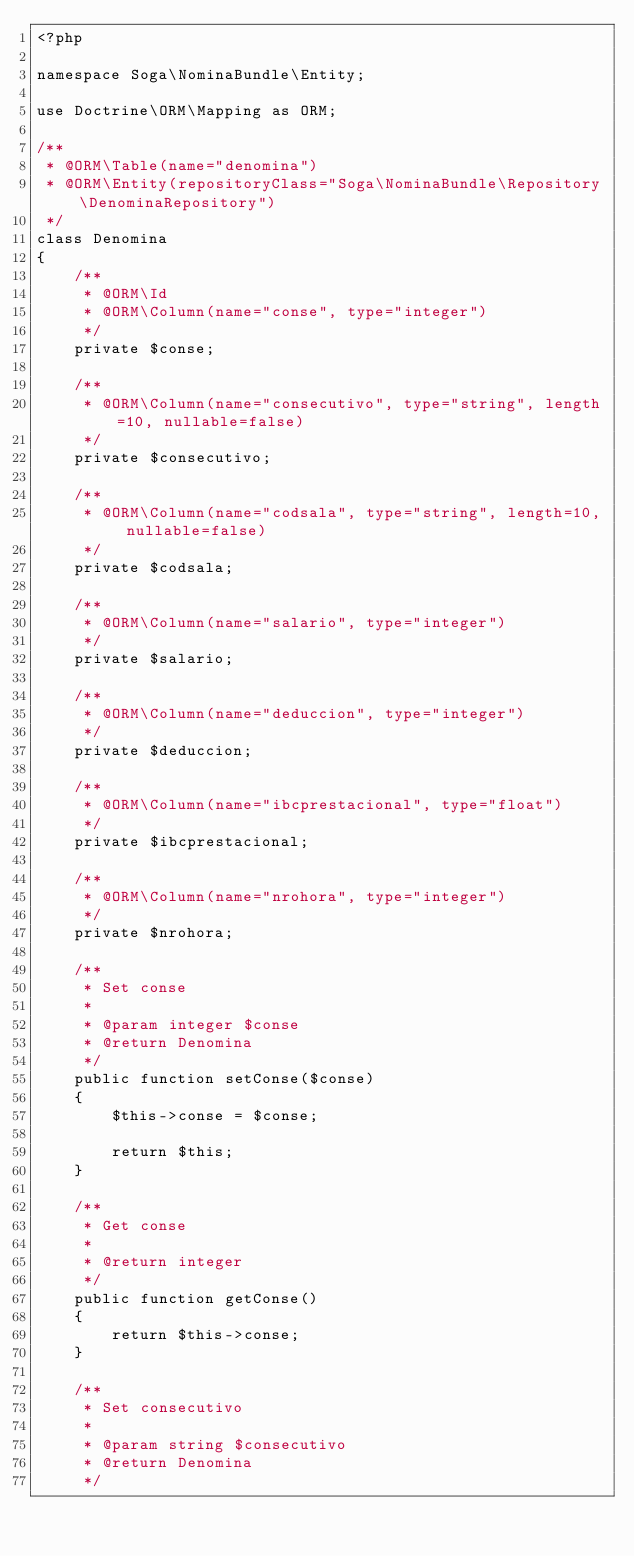<code> <loc_0><loc_0><loc_500><loc_500><_PHP_><?php

namespace Soga\NominaBundle\Entity;

use Doctrine\ORM\Mapping as ORM;

/**
 * @ORM\Table(name="denomina")
 * @ORM\Entity(repositoryClass="Soga\NominaBundle\Repository\DenominaRepository")
 */
class Denomina
{
    /**
     * @ORM\Id
     * @ORM\Column(name="conse", type="integer")
     */ 
    private $conse;
    
    /**
     * @ORM\Column(name="consecutivo", type="string", length=10, nullable=false)
     */    
    private $consecutivo;  
    
    /**
     * @ORM\Column(name="codsala", type="string", length=10, nullable=false)
     */    
    private $codsala;   

    /**
     * @ORM\Column(name="salario", type="integer")
     */    
    private $salario;       

    /**
     * @ORM\Column(name="deduccion", type="integer")
     */    
    private $deduccion;           
    
    /**
     * @ORM\Column(name="ibcprestacional", type="float")
     */    
    private $ibcprestacional;    

    /**
     * @ORM\Column(name="nrohora", type="integer")
     */    
    private $nrohora;     
    
    /**
     * Set conse
     *
     * @param integer $conse
     * @return Denomina
     */
    public function setConse($conse)
    {
        $this->conse = $conse;

        return $this;
    }

    /**
     * Get conse
     *
     * @return integer 
     */
    public function getConse()
    {
        return $this->conse;
    }

    /**
     * Set consecutivo
     *
     * @param string $consecutivo
     * @return Denomina
     */</code> 